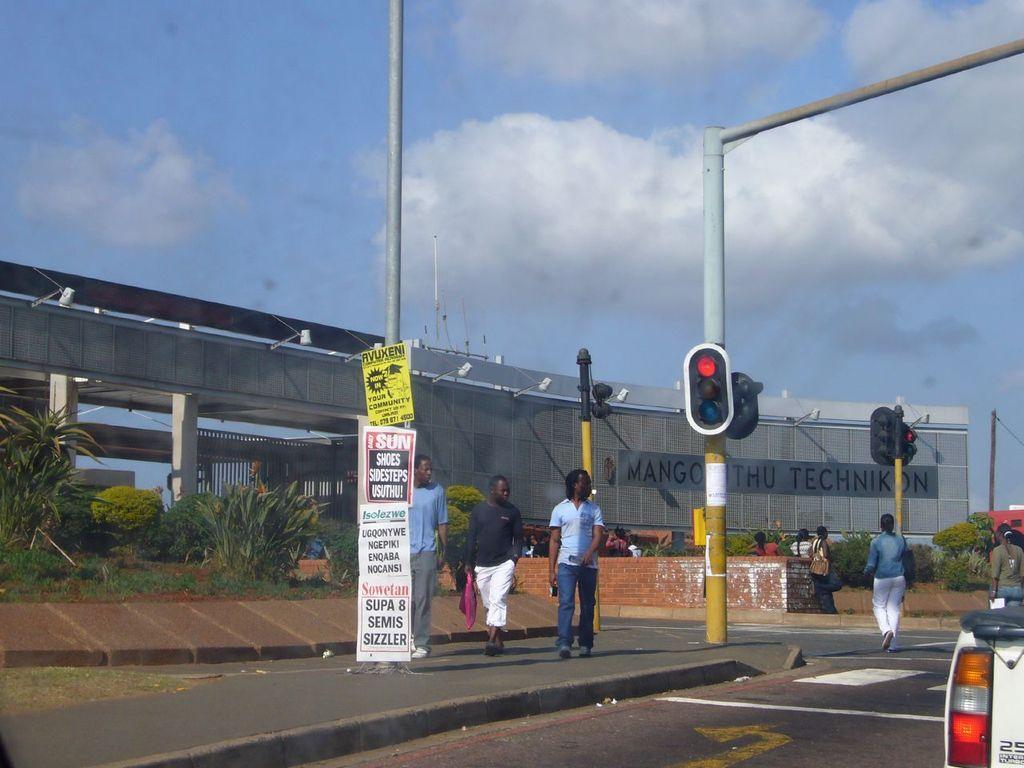In one or two sentences, can you explain what this image depicts? This image is clicked on the road. There are many people in this image. To the right, there is vehicle. At the bottom, there is road. To the left, there are plants and a bride. In the middle, there are signal lights fixed to the pole. 